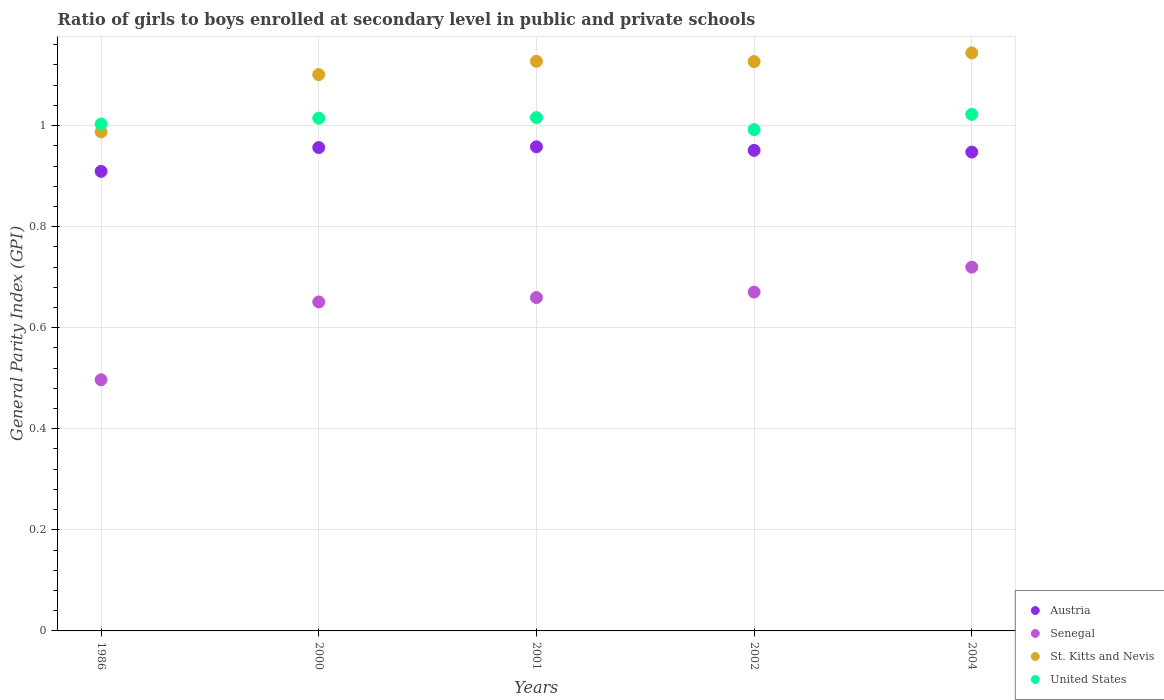How many different coloured dotlines are there?
Offer a terse response. 4. Is the number of dotlines equal to the number of legend labels?
Ensure brevity in your answer.  Yes. What is the general parity index in St. Kitts and Nevis in 2002?
Your answer should be very brief. 1.13. Across all years, what is the maximum general parity index in United States?
Ensure brevity in your answer.  1.02. Across all years, what is the minimum general parity index in Austria?
Give a very brief answer. 0.91. In which year was the general parity index in United States minimum?
Your answer should be very brief. 2002. What is the total general parity index in Senegal in the graph?
Keep it short and to the point. 3.2. What is the difference between the general parity index in St. Kitts and Nevis in 2000 and that in 2004?
Offer a terse response. -0.04. What is the difference between the general parity index in Austria in 2004 and the general parity index in St. Kitts and Nevis in 2002?
Your answer should be compact. -0.18. What is the average general parity index in Austria per year?
Your answer should be compact. 0.94. In the year 1986, what is the difference between the general parity index in Senegal and general parity index in Austria?
Ensure brevity in your answer.  -0.41. What is the ratio of the general parity index in United States in 2000 to that in 2001?
Offer a terse response. 1. Is the general parity index in Austria in 2001 less than that in 2004?
Make the answer very short. No. Is the difference between the general parity index in Senegal in 2002 and 2004 greater than the difference between the general parity index in Austria in 2002 and 2004?
Ensure brevity in your answer.  No. What is the difference between the highest and the second highest general parity index in St. Kitts and Nevis?
Ensure brevity in your answer.  0.02. What is the difference between the highest and the lowest general parity index in St. Kitts and Nevis?
Ensure brevity in your answer.  0.16. Is the sum of the general parity index in St. Kitts and Nevis in 2000 and 2002 greater than the maximum general parity index in United States across all years?
Give a very brief answer. Yes. Is it the case that in every year, the sum of the general parity index in Senegal and general parity index in St. Kitts and Nevis  is greater than the sum of general parity index in United States and general parity index in Austria?
Your answer should be compact. No. Is the general parity index in Senegal strictly less than the general parity index in Austria over the years?
Offer a very short reply. Yes. How many dotlines are there?
Offer a very short reply. 4. How many years are there in the graph?
Keep it short and to the point. 5. What is the difference between two consecutive major ticks on the Y-axis?
Your response must be concise. 0.2. Does the graph contain grids?
Provide a short and direct response. Yes. How are the legend labels stacked?
Keep it short and to the point. Vertical. What is the title of the graph?
Ensure brevity in your answer.  Ratio of girls to boys enrolled at secondary level in public and private schools. What is the label or title of the X-axis?
Provide a short and direct response. Years. What is the label or title of the Y-axis?
Make the answer very short. General Parity Index (GPI). What is the General Parity Index (GPI) of Austria in 1986?
Your answer should be compact. 0.91. What is the General Parity Index (GPI) of Senegal in 1986?
Offer a very short reply. 0.5. What is the General Parity Index (GPI) in St. Kitts and Nevis in 1986?
Your answer should be very brief. 0.99. What is the General Parity Index (GPI) of United States in 1986?
Provide a short and direct response. 1. What is the General Parity Index (GPI) of Austria in 2000?
Provide a succinct answer. 0.96. What is the General Parity Index (GPI) of Senegal in 2000?
Your answer should be compact. 0.65. What is the General Parity Index (GPI) in St. Kitts and Nevis in 2000?
Make the answer very short. 1.1. What is the General Parity Index (GPI) of United States in 2000?
Offer a terse response. 1.01. What is the General Parity Index (GPI) of Austria in 2001?
Offer a very short reply. 0.96. What is the General Parity Index (GPI) in Senegal in 2001?
Give a very brief answer. 0.66. What is the General Parity Index (GPI) of St. Kitts and Nevis in 2001?
Offer a terse response. 1.13. What is the General Parity Index (GPI) in United States in 2001?
Provide a short and direct response. 1.02. What is the General Parity Index (GPI) in Austria in 2002?
Give a very brief answer. 0.95. What is the General Parity Index (GPI) of Senegal in 2002?
Make the answer very short. 0.67. What is the General Parity Index (GPI) in St. Kitts and Nevis in 2002?
Your answer should be compact. 1.13. What is the General Parity Index (GPI) in United States in 2002?
Keep it short and to the point. 0.99. What is the General Parity Index (GPI) in Austria in 2004?
Your answer should be compact. 0.95. What is the General Parity Index (GPI) in Senegal in 2004?
Your answer should be compact. 0.72. What is the General Parity Index (GPI) of St. Kitts and Nevis in 2004?
Your response must be concise. 1.14. What is the General Parity Index (GPI) of United States in 2004?
Offer a terse response. 1.02. Across all years, what is the maximum General Parity Index (GPI) of Austria?
Offer a terse response. 0.96. Across all years, what is the maximum General Parity Index (GPI) in Senegal?
Keep it short and to the point. 0.72. Across all years, what is the maximum General Parity Index (GPI) of St. Kitts and Nevis?
Make the answer very short. 1.14. Across all years, what is the maximum General Parity Index (GPI) in United States?
Your answer should be very brief. 1.02. Across all years, what is the minimum General Parity Index (GPI) of Austria?
Provide a succinct answer. 0.91. Across all years, what is the minimum General Parity Index (GPI) in Senegal?
Provide a short and direct response. 0.5. Across all years, what is the minimum General Parity Index (GPI) of St. Kitts and Nevis?
Provide a short and direct response. 0.99. Across all years, what is the minimum General Parity Index (GPI) of United States?
Ensure brevity in your answer.  0.99. What is the total General Parity Index (GPI) of Austria in the graph?
Your answer should be compact. 4.72. What is the total General Parity Index (GPI) in Senegal in the graph?
Make the answer very short. 3.2. What is the total General Parity Index (GPI) of St. Kitts and Nevis in the graph?
Offer a very short reply. 5.49. What is the total General Parity Index (GPI) of United States in the graph?
Your answer should be very brief. 5.05. What is the difference between the General Parity Index (GPI) in Austria in 1986 and that in 2000?
Your answer should be very brief. -0.05. What is the difference between the General Parity Index (GPI) of Senegal in 1986 and that in 2000?
Your answer should be very brief. -0.15. What is the difference between the General Parity Index (GPI) in St. Kitts and Nevis in 1986 and that in 2000?
Offer a very short reply. -0.11. What is the difference between the General Parity Index (GPI) of United States in 1986 and that in 2000?
Ensure brevity in your answer.  -0.01. What is the difference between the General Parity Index (GPI) in Austria in 1986 and that in 2001?
Offer a very short reply. -0.05. What is the difference between the General Parity Index (GPI) in Senegal in 1986 and that in 2001?
Provide a succinct answer. -0.16. What is the difference between the General Parity Index (GPI) of St. Kitts and Nevis in 1986 and that in 2001?
Offer a terse response. -0.14. What is the difference between the General Parity Index (GPI) of United States in 1986 and that in 2001?
Keep it short and to the point. -0.01. What is the difference between the General Parity Index (GPI) of Austria in 1986 and that in 2002?
Your answer should be compact. -0.04. What is the difference between the General Parity Index (GPI) of Senegal in 1986 and that in 2002?
Ensure brevity in your answer.  -0.17. What is the difference between the General Parity Index (GPI) in St. Kitts and Nevis in 1986 and that in 2002?
Ensure brevity in your answer.  -0.14. What is the difference between the General Parity Index (GPI) of United States in 1986 and that in 2002?
Offer a terse response. 0.01. What is the difference between the General Parity Index (GPI) of Austria in 1986 and that in 2004?
Ensure brevity in your answer.  -0.04. What is the difference between the General Parity Index (GPI) in Senegal in 1986 and that in 2004?
Provide a short and direct response. -0.22. What is the difference between the General Parity Index (GPI) in St. Kitts and Nevis in 1986 and that in 2004?
Ensure brevity in your answer.  -0.16. What is the difference between the General Parity Index (GPI) in United States in 1986 and that in 2004?
Provide a short and direct response. -0.02. What is the difference between the General Parity Index (GPI) in Austria in 2000 and that in 2001?
Your response must be concise. -0. What is the difference between the General Parity Index (GPI) in Senegal in 2000 and that in 2001?
Your answer should be very brief. -0.01. What is the difference between the General Parity Index (GPI) of St. Kitts and Nevis in 2000 and that in 2001?
Offer a terse response. -0.03. What is the difference between the General Parity Index (GPI) in United States in 2000 and that in 2001?
Offer a very short reply. -0. What is the difference between the General Parity Index (GPI) in Austria in 2000 and that in 2002?
Your answer should be compact. 0.01. What is the difference between the General Parity Index (GPI) of Senegal in 2000 and that in 2002?
Your response must be concise. -0.02. What is the difference between the General Parity Index (GPI) of St. Kitts and Nevis in 2000 and that in 2002?
Provide a succinct answer. -0.03. What is the difference between the General Parity Index (GPI) of United States in 2000 and that in 2002?
Offer a very short reply. 0.02. What is the difference between the General Parity Index (GPI) in Austria in 2000 and that in 2004?
Your answer should be compact. 0.01. What is the difference between the General Parity Index (GPI) of Senegal in 2000 and that in 2004?
Make the answer very short. -0.07. What is the difference between the General Parity Index (GPI) of St. Kitts and Nevis in 2000 and that in 2004?
Your answer should be compact. -0.04. What is the difference between the General Parity Index (GPI) in United States in 2000 and that in 2004?
Keep it short and to the point. -0.01. What is the difference between the General Parity Index (GPI) in Austria in 2001 and that in 2002?
Keep it short and to the point. 0.01. What is the difference between the General Parity Index (GPI) in Senegal in 2001 and that in 2002?
Your answer should be compact. -0.01. What is the difference between the General Parity Index (GPI) of St. Kitts and Nevis in 2001 and that in 2002?
Provide a succinct answer. 0. What is the difference between the General Parity Index (GPI) in United States in 2001 and that in 2002?
Provide a short and direct response. 0.02. What is the difference between the General Parity Index (GPI) in Austria in 2001 and that in 2004?
Give a very brief answer. 0.01. What is the difference between the General Parity Index (GPI) of Senegal in 2001 and that in 2004?
Your response must be concise. -0.06. What is the difference between the General Parity Index (GPI) of St. Kitts and Nevis in 2001 and that in 2004?
Ensure brevity in your answer.  -0.02. What is the difference between the General Parity Index (GPI) of United States in 2001 and that in 2004?
Ensure brevity in your answer.  -0.01. What is the difference between the General Parity Index (GPI) in Austria in 2002 and that in 2004?
Your response must be concise. 0. What is the difference between the General Parity Index (GPI) of Senegal in 2002 and that in 2004?
Your answer should be compact. -0.05. What is the difference between the General Parity Index (GPI) in St. Kitts and Nevis in 2002 and that in 2004?
Offer a terse response. -0.02. What is the difference between the General Parity Index (GPI) of United States in 2002 and that in 2004?
Your response must be concise. -0.03. What is the difference between the General Parity Index (GPI) of Austria in 1986 and the General Parity Index (GPI) of Senegal in 2000?
Offer a terse response. 0.26. What is the difference between the General Parity Index (GPI) in Austria in 1986 and the General Parity Index (GPI) in St. Kitts and Nevis in 2000?
Give a very brief answer. -0.19. What is the difference between the General Parity Index (GPI) in Austria in 1986 and the General Parity Index (GPI) in United States in 2000?
Keep it short and to the point. -0.11. What is the difference between the General Parity Index (GPI) of Senegal in 1986 and the General Parity Index (GPI) of St. Kitts and Nevis in 2000?
Provide a short and direct response. -0.6. What is the difference between the General Parity Index (GPI) in Senegal in 1986 and the General Parity Index (GPI) in United States in 2000?
Keep it short and to the point. -0.52. What is the difference between the General Parity Index (GPI) in St. Kitts and Nevis in 1986 and the General Parity Index (GPI) in United States in 2000?
Offer a very short reply. -0.03. What is the difference between the General Parity Index (GPI) in Austria in 1986 and the General Parity Index (GPI) in Senegal in 2001?
Offer a very short reply. 0.25. What is the difference between the General Parity Index (GPI) of Austria in 1986 and the General Parity Index (GPI) of St. Kitts and Nevis in 2001?
Keep it short and to the point. -0.22. What is the difference between the General Parity Index (GPI) in Austria in 1986 and the General Parity Index (GPI) in United States in 2001?
Provide a succinct answer. -0.11. What is the difference between the General Parity Index (GPI) in Senegal in 1986 and the General Parity Index (GPI) in St. Kitts and Nevis in 2001?
Your response must be concise. -0.63. What is the difference between the General Parity Index (GPI) of Senegal in 1986 and the General Parity Index (GPI) of United States in 2001?
Provide a short and direct response. -0.52. What is the difference between the General Parity Index (GPI) in St. Kitts and Nevis in 1986 and the General Parity Index (GPI) in United States in 2001?
Offer a terse response. -0.03. What is the difference between the General Parity Index (GPI) in Austria in 1986 and the General Parity Index (GPI) in Senegal in 2002?
Make the answer very short. 0.24. What is the difference between the General Parity Index (GPI) of Austria in 1986 and the General Parity Index (GPI) of St. Kitts and Nevis in 2002?
Keep it short and to the point. -0.22. What is the difference between the General Parity Index (GPI) in Austria in 1986 and the General Parity Index (GPI) in United States in 2002?
Your answer should be compact. -0.08. What is the difference between the General Parity Index (GPI) in Senegal in 1986 and the General Parity Index (GPI) in St. Kitts and Nevis in 2002?
Make the answer very short. -0.63. What is the difference between the General Parity Index (GPI) of Senegal in 1986 and the General Parity Index (GPI) of United States in 2002?
Keep it short and to the point. -0.5. What is the difference between the General Parity Index (GPI) in St. Kitts and Nevis in 1986 and the General Parity Index (GPI) in United States in 2002?
Offer a terse response. -0. What is the difference between the General Parity Index (GPI) of Austria in 1986 and the General Parity Index (GPI) of Senegal in 2004?
Offer a very short reply. 0.19. What is the difference between the General Parity Index (GPI) in Austria in 1986 and the General Parity Index (GPI) in St. Kitts and Nevis in 2004?
Your answer should be compact. -0.23. What is the difference between the General Parity Index (GPI) of Austria in 1986 and the General Parity Index (GPI) of United States in 2004?
Provide a short and direct response. -0.11. What is the difference between the General Parity Index (GPI) of Senegal in 1986 and the General Parity Index (GPI) of St. Kitts and Nevis in 2004?
Ensure brevity in your answer.  -0.65. What is the difference between the General Parity Index (GPI) of Senegal in 1986 and the General Parity Index (GPI) of United States in 2004?
Give a very brief answer. -0.53. What is the difference between the General Parity Index (GPI) of St. Kitts and Nevis in 1986 and the General Parity Index (GPI) of United States in 2004?
Your answer should be very brief. -0.03. What is the difference between the General Parity Index (GPI) in Austria in 2000 and the General Parity Index (GPI) in Senegal in 2001?
Ensure brevity in your answer.  0.3. What is the difference between the General Parity Index (GPI) of Austria in 2000 and the General Parity Index (GPI) of St. Kitts and Nevis in 2001?
Keep it short and to the point. -0.17. What is the difference between the General Parity Index (GPI) in Austria in 2000 and the General Parity Index (GPI) in United States in 2001?
Your answer should be very brief. -0.06. What is the difference between the General Parity Index (GPI) in Senegal in 2000 and the General Parity Index (GPI) in St. Kitts and Nevis in 2001?
Your answer should be compact. -0.48. What is the difference between the General Parity Index (GPI) of Senegal in 2000 and the General Parity Index (GPI) of United States in 2001?
Your response must be concise. -0.36. What is the difference between the General Parity Index (GPI) of St. Kitts and Nevis in 2000 and the General Parity Index (GPI) of United States in 2001?
Provide a succinct answer. 0.09. What is the difference between the General Parity Index (GPI) of Austria in 2000 and the General Parity Index (GPI) of Senegal in 2002?
Your answer should be compact. 0.29. What is the difference between the General Parity Index (GPI) of Austria in 2000 and the General Parity Index (GPI) of St. Kitts and Nevis in 2002?
Keep it short and to the point. -0.17. What is the difference between the General Parity Index (GPI) in Austria in 2000 and the General Parity Index (GPI) in United States in 2002?
Your answer should be compact. -0.04. What is the difference between the General Parity Index (GPI) of Senegal in 2000 and the General Parity Index (GPI) of St. Kitts and Nevis in 2002?
Provide a short and direct response. -0.48. What is the difference between the General Parity Index (GPI) in Senegal in 2000 and the General Parity Index (GPI) in United States in 2002?
Provide a short and direct response. -0.34. What is the difference between the General Parity Index (GPI) in St. Kitts and Nevis in 2000 and the General Parity Index (GPI) in United States in 2002?
Provide a short and direct response. 0.11. What is the difference between the General Parity Index (GPI) of Austria in 2000 and the General Parity Index (GPI) of Senegal in 2004?
Your answer should be compact. 0.24. What is the difference between the General Parity Index (GPI) in Austria in 2000 and the General Parity Index (GPI) in St. Kitts and Nevis in 2004?
Offer a terse response. -0.19. What is the difference between the General Parity Index (GPI) of Austria in 2000 and the General Parity Index (GPI) of United States in 2004?
Keep it short and to the point. -0.07. What is the difference between the General Parity Index (GPI) in Senegal in 2000 and the General Parity Index (GPI) in St. Kitts and Nevis in 2004?
Keep it short and to the point. -0.49. What is the difference between the General Parity Index (GPI) of Senegal in 2000 and the General Parity Index (GPI) of United States in 2004?
Provide a succinct answer. -0.37. What is the difference between the General Parity Index (GPI) of St. Kitts and Nevis in 2000 and the General Parity Index (GPI) of United States in 2004?
Your answer should be very brief. 0.08. What is the difference between the General Parity Index (GPI) in Austria in 2001 and the General Parity Index (GPI) in Senegal in 2002?
Keep it short and to the point. 0.29. What is the difference between the General Parity Index (GPI) of Austria in 2001 and the General Parity Index (GPI) of St. Kitts and Nevis in 2002?
Ensure brevity in your answer.  -0.17. What is the difference between the General Parity Index (GPI) of Austria in 2001 and the General Parity Index (GPI) of United States in 2002?
Offer a very short reply. -0.03. What is the difference between the General Parity Index (GPI) of Senegal in 2001 and the General Parity Index (GPI) of St. Kitts and Nevis in 2002?
Ensure brevity in your answer.  -0.47. What is the difference between the General Parity Index (GPI) of Senegal in 2001 and the General Parity Index (GPI) of United States in 2002?
Provide a short and direct response. -0.33. What is the difference between the General Parity Index (GPI) of St. Kitts and Nevis in 2001 and the General Parity Index (GPI) of United States in 2002?
Your response must be concise. 0.14. What is the difference between the General Parity Index (GPI) in Austria in 2001 and the General Parity Index (GPI) in Senegal in 2004?
Offer a very short reply. 0.24. What is the difference between the General Parity Index (GPI) in Austria in 2001 and the General Parity Index (GPI) in St. Kitts and Nevis in 2004?
Make the answer very short. -0.19. What is the difference between the General Parity Index (GPI) in Austria in 2001 and the General Parity Index (GPI) in United States in 2004?
Your response must be concise. -0.06. What is the difference between the General Parity Index (GPI) in Senegal in 2001 and the General Parity Index (GPI) in St. Kitts and Nevis in 2004?
Your response must be concise. -0.48. What is the difference between the General Parity Index (GPI) of Senegal in 2001 and the General Parity Index (GPI) of United States in 2004?
Make the answer very short. -0.36. What is the difference between the General Parity Index (GPI) of St. Kitts and Nevis in 2001 and the General Parity Index (GPI) of United States in 2004?
Provide a short and direct response. 0.1. What is the difference between the General Parity Index (GPI) of Austria in 2002 and the General Parity Index (GPI) of Senegal in 2004?
Ensure brevity in your answer.  0.23. What is the difference between the General Parity Index (GPI) in Austria in 2002 and the General Parity Index (GPI) in St. Kitts and Nevis in 2004?
Provide a succinct answer. -0.19. What is the difference between the General Parity Index (GPI) of Austria in 2002 and the General Parity Index (GPI) of United States in 2004?
Your answer should be compact. -0.07. What is the difference between the General Parity Index (GPI) in Senegal in 2002 and the General Parity Index (GPI) in St. Kitts and Nevis in 2004?
Keep it short and to the point. -0.47. What is the difference between the General Parity Index (GPI) in Senegal in 2002 and the General Parity Index (GPI) in United States in 2004?
Provide a succinct answer. -0.35. What is the difference between the General Parity Index (GPI) in St. Kitts and Nevis in 2002 and the General Parity Index (GPI) in United States in 2004?
Offer a very short reply. 0.1. What is the average General Parity Index (GPI) in Austria per year?
Make the answer very short. 0.94. What is the average General Parity Index (GPI) of Senegal per year?
Ensure brevity in your answer.  0.64. What is the average General Parity Index (GPI) in St. Kitts and Nevis per year?
Keep it short and to the point. 1.1. What is the average General Parity Index (GPI) of United States per year?
Offer a very short reply. 1.01. In the year 1986, what is the difference between the General Parity Index (GPI) in Austria and General Parity Index (GPI) in Senegal?
Provide a short and direct response. 0.41. In the year 1986, what is the difference between the General Parity Index (GPI) in Austria and General Parity Index (GPI) in St. Kitts and Nevis?
Provide a succinct answer. -0.08. In the year 1986, what is the difference between the General Parity Index (GPI) of Austria and General Parity Index (GPI) of United States?
Give a very brief answer. -0.09. In the year 1986, what is the difference between the General Parity Index (GPI) of Senegal and General Parity Index (GPI) of St. Kitts and Nevis?
Your response must be concise. -0.49. In the year 1986, what is the difference between the General Parity Index (GPI) in Senegal and General Parity Index (GPI) in United States?
Make the answer very short. -0.51. In the year 1986, what is the difference between the General Parity Index (GPI) of St. Kitts and Nevis and General Parity Index (GPI) of United States?
Keep it short and to the point. -0.02. In the year 2000, what is the difference between the General Parity Index (GPI) of Austria and General Parity Index (GPI) of Senegal?
Give a very brief answer. 0.31. In the year 2000, what is the difference between the General Parity Index (GPI) in Austria and General Parity Index (GPI) in St. Kitts and Nevis?
Give a very brief answer. -0.14. In the year 2000, what is the difference between the General Parity Index (GPI) in Austria and General Parity Index (GPI) in United States?
Offer a very short reply. -0.06. In the year 2000, what is the difference between the General Parity Index (GPI) of Senegal and General Parity Index (GPI) of St. Kitts and Nevis?
Ensure brevity in your answer.  -0.45. In the year 2000, what is the difference between the General Parity Index (GPI) in Senegal and General Parity Index (GPI) in United States?
Ensure brevity in your answer.  -0.36. In the year 2000, what is the difference between the General Parity Index (GPI) in St. Kitts and Nevis and General Parity Index (GPI) in United States?
Provide a short and direct response. 0.09. In the year 2001, what is the difference between the General Parity Index (GPI) in Austria and General Parity Index (GPI) in Senegal?
Your answer should be compact. 0.3. In the year 2001, what is the difference between the General Parity Index (GPI) of Austria and General Parity Index (GPI) of St. Kitts and Nevis?
Make the answer very short. -0.17. In the year 2001, what is the difference between the General Parity Index (GPI) in Austria and General Parity Index (GPI) in United States?
Ensure brevity in your answer.  -0.06. In the year 2001, what is the difference between the General Parity Index (GPI) of Senegal and General Parity Index (GPI) of St. Kitts and Nevis?
Keep it short and to the point. -0.47. In the year 2001, what is the difference between the General Parity Index (GPI) in Senegal and General Parity Index (GPI) in United States?
Your answer should be compact. -0.36. In the year 2001, what is the difference between the General Parity Index (GPI) of St. Kitts and Nevis and General Parity Index (GPI) of United States?
Your response must be concise. 0.11. In the year 2002, what is the difference between the General Parity Index (GPI) in Austria and General Parity Index (GPI) in Senegal?
Give a very brief answer. 0.28. In the year 2002, what is the difference between the General Parity Index (GPI) of Austria and General Parity Index (GPI) of St. Kitts and Nevis?
Keep it short and to the point. -0.18. In the year 2002, what is the difference between the General Parity Index (GPI) in Austria and General Parity Index (GPI) in United States?
Provide a short and direct response. -0.04. In the year 2002, what is the difference between the General Parity Index (GPI) of Senegal and General Parity Index (GPI) of St. Kitts and Nevis?
Your answer should be very brief. -0.46. In the year 2002, what is the difference between the General Parity Index (GPI) in Senegal and General Parity Index (GPI) in United States?
Your answer should be compact. -0.32. In the year 2002, what is the difference between the General Parity Index (GPI) in St. Kitts and Nevis and General Parity Index (GPI) in United States?
Your answer should be very brief. 0.13. In the year 2004, what is the difference between the General Parity Index (GPI) of Austria and General Parity Index (GPI) of Senegal?
Offer a very short reply. 0.23. In the year 2004, what is the difference between the General Parity Index (GPI) of Austria and General Parity Index (GPI) of St. Kitts and Nevis?
Your answer should be compact. -0.2. In the year 2004, what is the difference between the General Parity Index (GPI) of Austria and General Parity Index (GPI) of United States?
Your response must be concise. -0.07. In the year 2004, what is the difference between the General Parity Index (GPI) of Senegal and General Parity Index (GPI) of St. Kitts and Nevis?
Give a very brief answer. -0.42. In the year 2004, what is the difference between the General Parity Index (GPI) in Senegal and General Parity Index (GPI) in United States?
Your answer should be compact. -0.3. In the year 2004, what is the difference between the General Parity Index (GPI) of St. Kitts and Nevis and General Parity Index (GPI) of United States?
Keep it short and to the point. 0.12. What is the ratio of the General Parity Index (GPI) of Austria in 1986 to that in 2000?
Your response must be concise. 0.95. What is the ratio of the General Parity Index (GPI) in Senegal in 1986 to that in 2000?
Your answer should be compact. 0.76. What is the ratio of the General Parity Index (GPI) of St. Kitts and Nevis in 1986 to that in 2000?
Make the answer very short. 0.9. What is the ratio of the General Parity Index (GPI) in United States in 1986 to that in 2000?
Give a very brief answer. 0.99. What is the ratio of the General Parity Index (GPI) in Austria in 1986 to that in 2001?
Offer a very short reply. 0.95. What is the ratio of the General Parity Index (GPI) of Senegal in 1986 to that in 2001?
Offer a very short reply. 0.75. What is the ratio of the General Parity Index (GPI) of St. Kitts and Nevis in 1986 to that in 2001?
Ensure brevity in your answer.  0.88. What is the ratio of the General Parity Index (GPI) in United States in 1986 to that in 2001?
Your answer should be very brief. 0.99. What is the ratio of the General Parity Index (GPI) of Austria in 1986 to that in 2002?
Offer a very short reply. 0.96. What is the ratio of the General Parity Index (GPI) in Senegal in 1986 to that in 2002?
Provide a succinct answer. 0.74. What is the ratio of the General Parity Index (GPI) of St. Kitts and Nevis in 1986 to that in 2002?
Make the answer very short. 0.88. What is the ratio of the General Parity Index (GPI) in United States in 1986 to that in 2002?
Your answer should be very brief. 1.01. What is the ratio of the General Parity Index (GPI) in Austria in 1986 to that in 2004?
Give a very brief answer. 0.96. What is the ratio of the General Parity Index (GPI) of Senegal in 1986 to that in 2004?
Offer a very short reply. 0.69. What is the ratio of the General Parity Index (GPI) of St. Kitts and Nevis in 1986 to that in 2004?
Provide a short and direct response. 0.86. What is the ratio of the General Parity Index (GPI) in United States in 1986 to that in 2004?
Your answer should be very brief. 0.98. What is the ratio of the General Parity Index (GPI) of Senegal in 2000 to that in 2001?
Give a very brief answer. 0.99. What is the ratio of the General Parity Index (GPI) of St. Kitts and Nevis in 2000 to that in 2001?
Provide a succinct answer. 0.98. What is the ratio of the General Parity Index (GPI) in St. Kitts and Nevis in 2000 to that in 2002?
Your answer should be very brief. 0.98. What is the ratio of the General Parity Index (GPI) in United States in 2000 to that in 2002?
Your response must be concise. 1.02. What is the ratio of the General Parity Index (GPI) of Austria in 2000 to that in 2004?
Offer a terse response. 1.01. What is the ratio of the General Parity Index (GPI) in Senegal in 2000 to that in 2004?
Keep it short and to the point. 0.9. What is the ratio of the General Parity Index (GPI) in St. Kitts and Nevis in 2000 to that in 2004?
Offer a very short reply. 0.96. What is the ratio of the General Parity Index (GPI) of Austria in 2001 to that in 2002?
Provide a short and direct response. 1.01. What is the ratio of the General Parity Index (GPI) of Senegal in 2001 to that in 2002?
Offer a very short reply. 0.98. What is the ratio of the General Parity Index (GPI) of United States in 2001 to that in 2002?
Give a very brief answer. 1.02. What is the ratio of the General Parity Index (GPI) in Austria in 2001 to that in 2004?
Offer a very short reply. 1.01. What is the ratio of the General Parity Index (GPI) of Senegal in 2001 to that in 2004?
Your response must be concise. 0.92. What is the ratio of the General Parity Index (GPI) of St. Kitts and Nevis in 2001 to that in 2004?
Your response must be concise. 0.99. What is the ratio of the General Parity Index (GPI) of United States in 2001 to that in 2004?
Offer a very short reply. 0.99. What is the ratio of the General Parity Index (GPI) of Senegal in 2002 to that in 2004?
Offer a very short reply. 0.93. What is the ratio of the General Parity Index (GPI) of United States in 2002 to that in 2004?
Ensure brevity in your answer.  0.97. What is the difference between the highest and the second highest General Parity Index (GPI) of Austria?
Keep it short and to the point. 0. What is the difference between the highest and the second highest General Parity Index (GPI) in Senegal?
Offer a terse response. 0.05. What is the difference between the highest and the second highest General Parity Index (GPI) of St. Kitts and Nevis?
Make the answer very short. 0.02. What is the difference between the highest and the second highest General Parity Index (GPI) in United States?
Ensure brevity in your answer.  0.01. What is the difference between the highest and the lowest General Parity Index (GPI) in Austria?
Your response must be concise. 0.05. What is the difference between the highest and the lowest General Parity Index (GPI) in Senegal?
Offer a terse response. 0.22. What is the difference between the highest and the lowest General Parity Index (GPI) in St. Kitts and Nevis?
Provide a succinct answer. 0.16. What is the difference between the highest and the lowest General Parity Index (GPI) of United States?
Offer a very short reply. 0.03. 